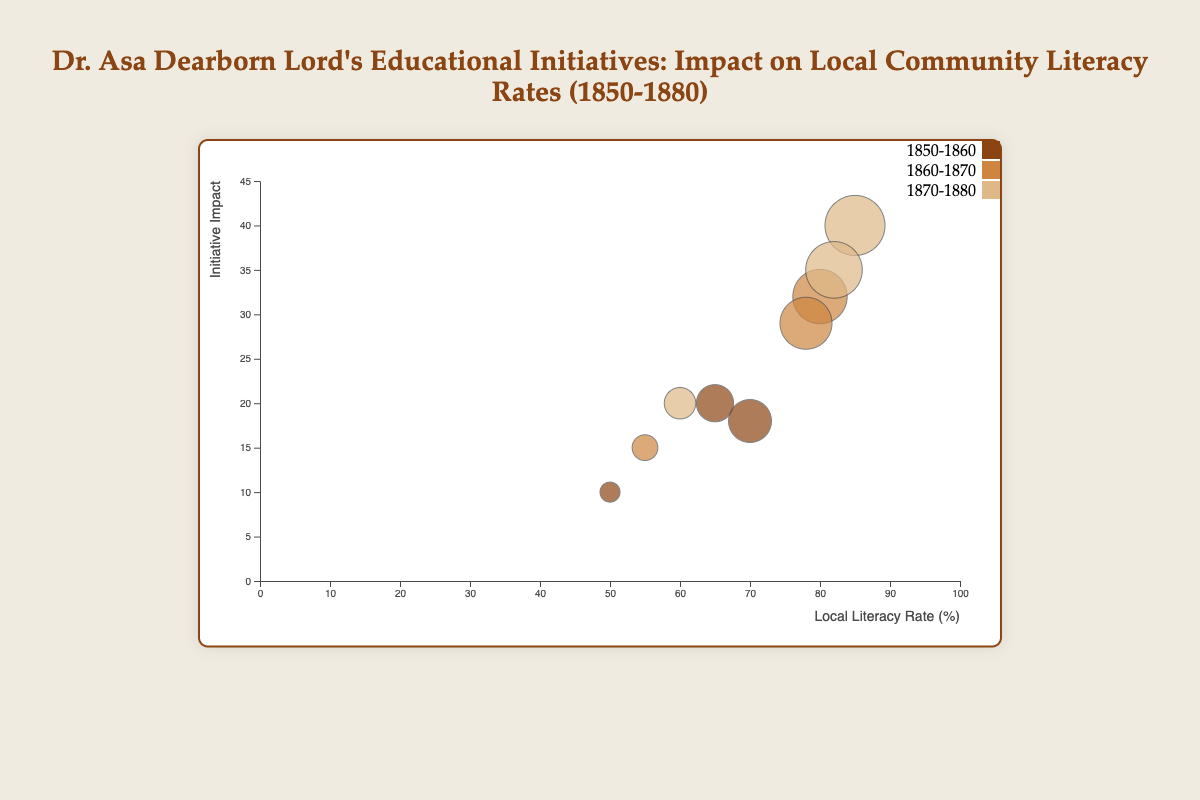Which age group saw the highest local literacy rate during the 1870-1880 period? Identify the age groups within the 1870-1880 period and compare their literacy rates. Young Adults: 85%, Adults: 82%, Middle-aged: 60%. The highest among these is Young Adults with 85%.
Answer: Young Adults What is the average initiative impact for the 21-30 age group across all periods? Extract the initiative impact values for the 21-30 age group: 18, 29, 35. Calculate their average: (18 + 29 + 35)/3 = 27.33.
Answer: 27.33 Which time period showed the greatest increase in literacy rate for the Young Adults age group? Compare the literacy rates of Young Adults across time periods: 10-20 (65%), 10-20 (80%), 10-20 (85%). The increase from 1850-1860 to 1860-1870 is 80 - 65 = 15, the increase from 1860-1870 to 1870-1880 is 85 - 80 = 5. The greatest increase is from 1850-1860 to 1860-1870.
Answer: 1850-1860 to 1860-1870 How does the initiative impact for the 31-40 age group in 1870-1880 compare to their impact in 1850-1860? The initiative impact for the 31-40 age group in 1870-1880 is 20, while in 1850-1860 it is 10. Therefore, the difference is 20 - 10 = 10.
Answer: 10 increase Which age group had the smallest bubble size in the figure? Bubble size represents the local literacy rate. Identify the smallest bubble by comparing literacy rates: 65%, 70%, 50%, 80%, 78%, 55%, 85%, 82%, 60%. The smallest bubble corresponds to 50% (Middle-aged group in 1850-1860).
Answer: Middle-aged (1850-1860) By how much did the local literacy rate for Middle-aged individuals change from 1850-1860 to 1870-1880? The local literacy rate for the Middle-aged group is 50% in 1850-1860 and 60% in 1870-1880. The change is 60 - 50 = 10.
Answer: 10 increase Which period has the highest average literacy rate across all age groups? Calculate the average literacy rate for each period: 
1850-1860 (65+70+50)/3 = 61.67; 
1860-1870 (80+78+55)/3 = 71; 
1870-1880 (85+82+60)/3 = 75.67. 
The highest average literacy rate is for 1870-1880.
Answer: 1870-1880 What is the relationship between local literacy rate and initiative impact for Adults aged 21-30 in the 1860-1870 period? For the 21-30 age group in 1860-1870, the literacy rate is 78%, and the initiative impact is 29. Observing the bubble, we notice that higher literacy rate corresponds with a relatively high initiative impact, suggesting a positive correlation.
Answer: Positive correlation 